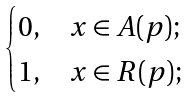<formula> <loc_0><loc_0><loc_500><loc_500>\begin{cases} 0 , & x \in A ( p ) ; \\ 1 , & x \in R ( p ) ; \end{cases}</formula> 